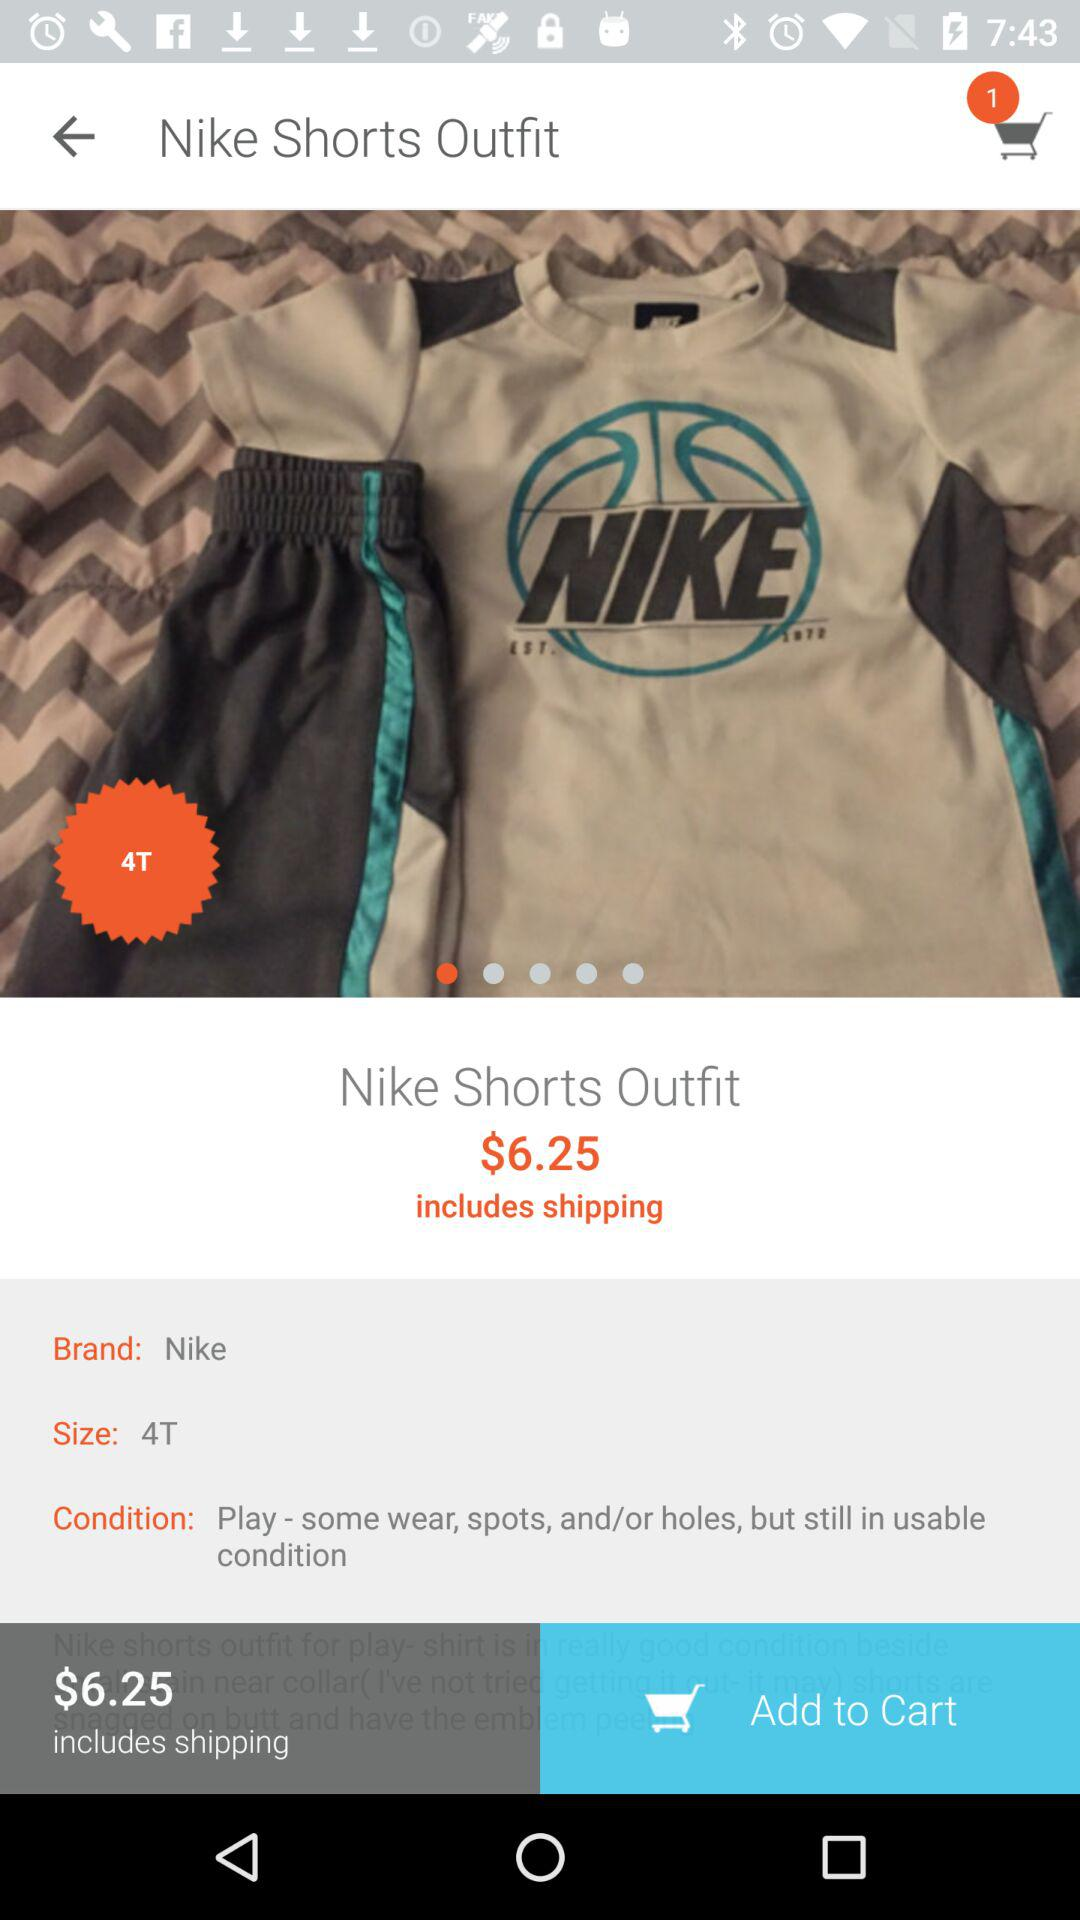What is the size of the outfit? The size is 4T. 